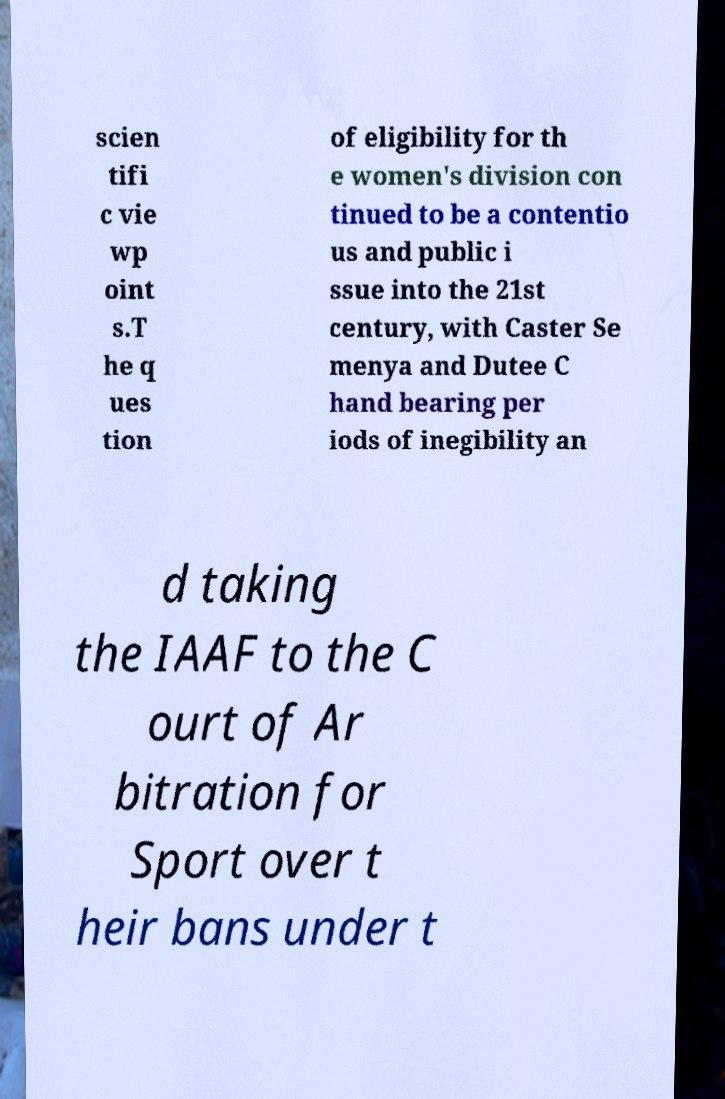For documentation purposes, I need the text within this image transcribed. Could you provide that? scien tifi c vie wp oint s.T he q ues tion of eligibility for th e women's division con tinued to be a contentio us and public i ssue into the 21st century, with Caster Se menya and Dutee C hand bearing per iods of inegibility an d taking the IAAF to the C ourt of Ar bitration for Sport over t heir bans under t 